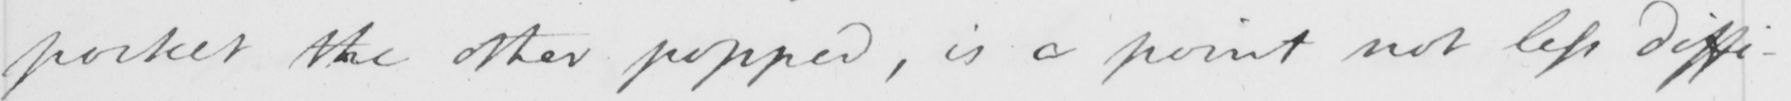What does this handwritten line say? pocket the other popped , is a point not less diffi- 